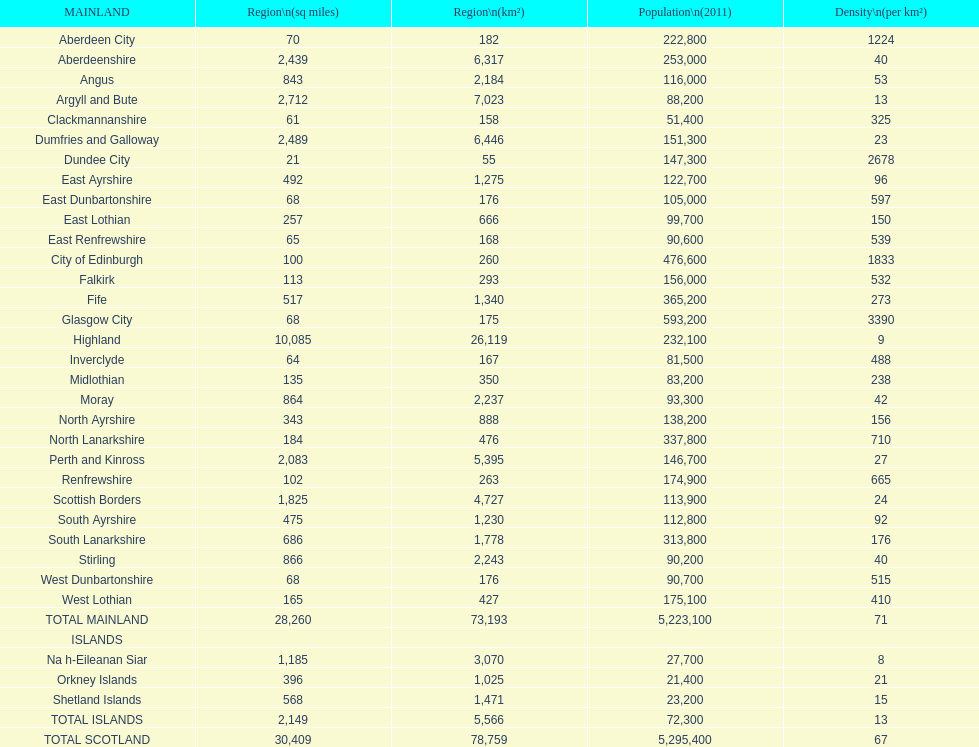What is the number of people living in angus in 2011? 116,000. 